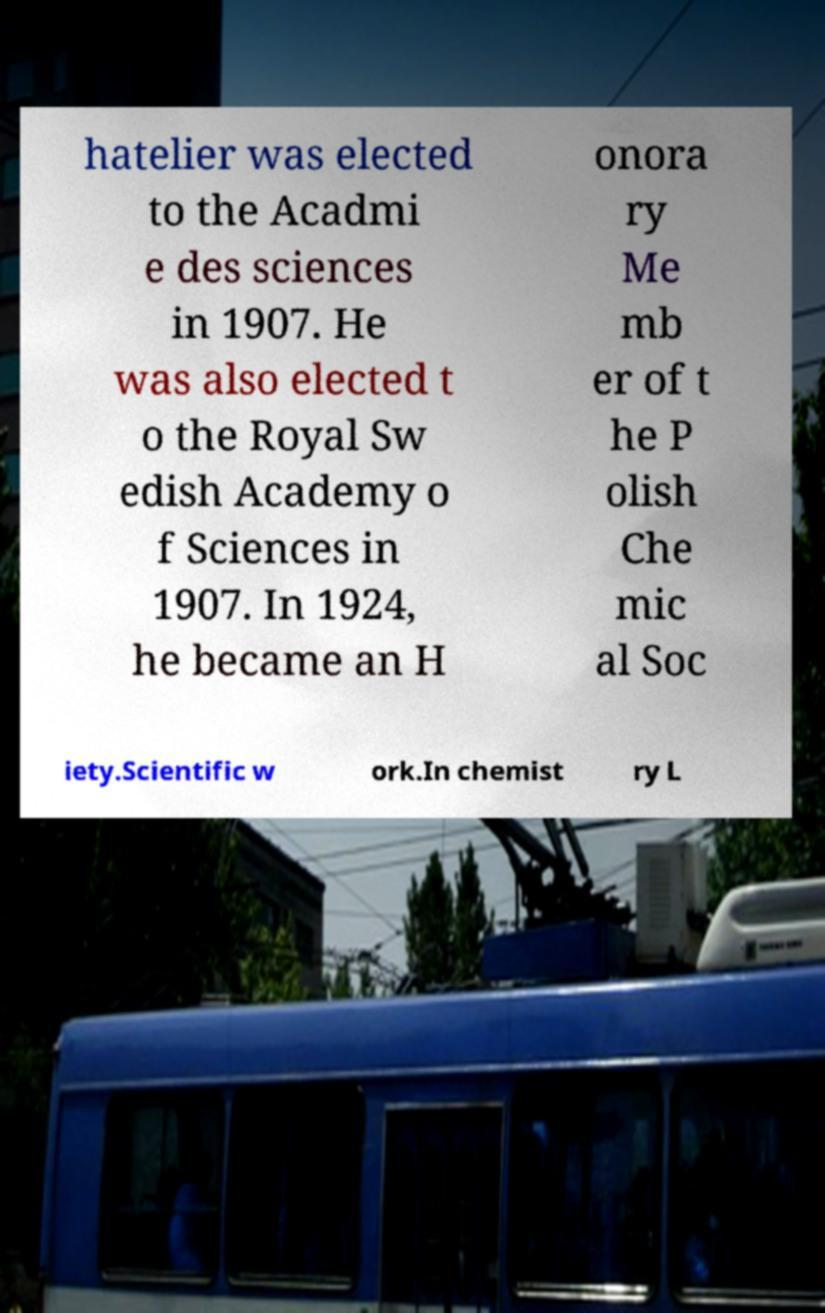Could you extract and type out the text from this image? hatelier was elected to the Acadmi e des sciences in 1907. He was also elected t o the Royal Sw edish Academy o f Sciences in 1907. In 1924, he became an H onora ry Me mb er of t he P olish Che mic al Soc iety.Scientific w ork.In chemist ry L 